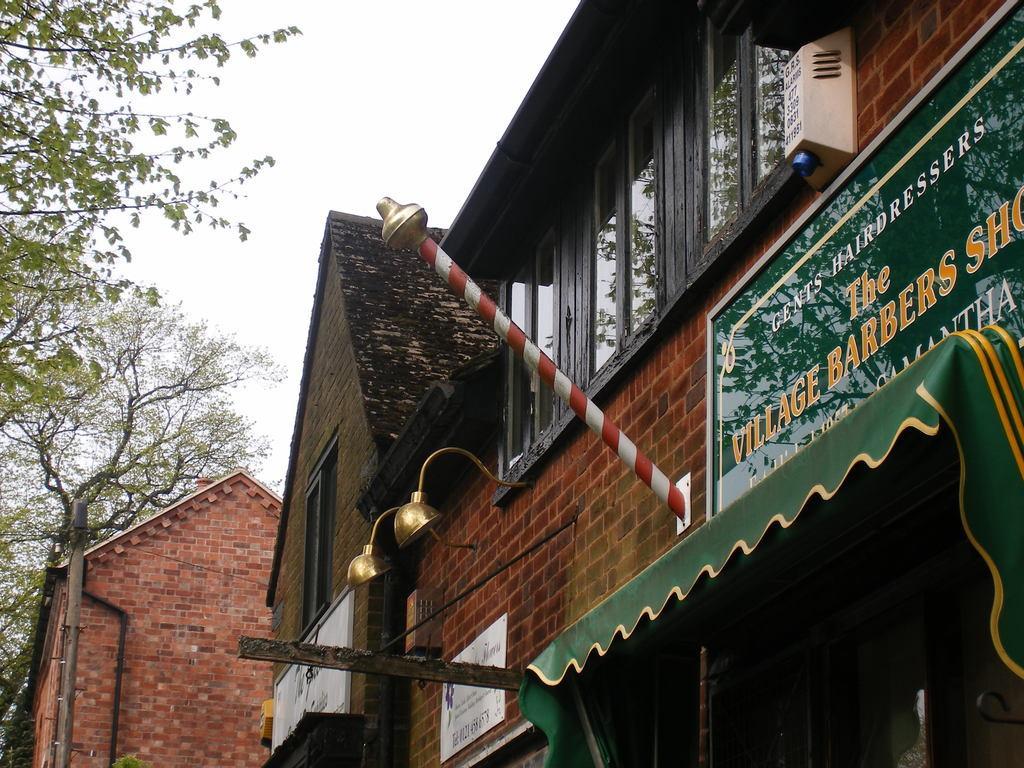Can you describe this image briefly? In this image there are shops, on that there is a board on that board there is some text, on the left side there are trees on the top there is the sky. 